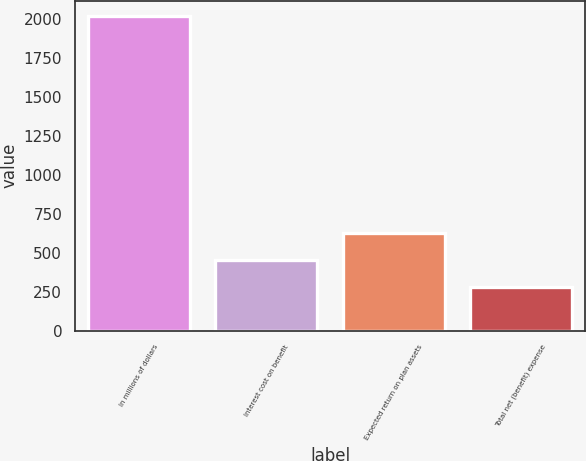Convert chart to OTSL. <chart><loc_0><loc_0><loc_500><loc_500><bar_chart><fcel>In millions of dollars<fcel>Interest cost on benefit<fcel>Expected return on plan assets<fcel>Total net (benefit) expense<nl><fcel>2015<fcel>454.4<fcel>627.8<fcel>281<nl></chart> 